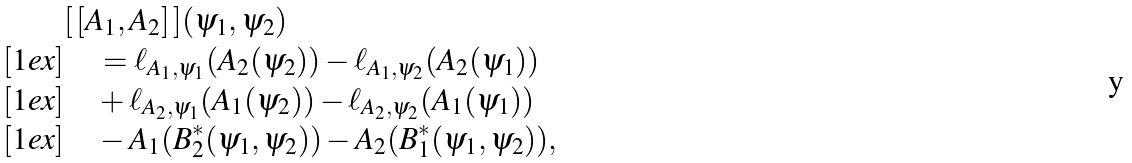Convert formula to latex. <formula><loc_0><loc_0><loc_500><loc_500>& [ \, [ A _ { 1 } , A _ { 2 } ] \, ] ( \psi _ { 1 } , \psi _ { 2 } ) \\ [ 1 e x ] & \quad = \ell _ { A _ { 1 } , \psi _ { 1 } } ( A _ { 2 } ( \psi _ { 2 } ) ) - \ell _ { A _ { 1 } , \psi _ { 2 } } ( A _ { 2 } ( \psi _ { 1 } ) ) \\ [ 1 e x ] & \quad + \ell _ { A _ { 2 } , \psi _ { 1 } } ( A _ { 1 } ( \psi _ { 2 } ) ) - \ell _ { A _ { 2 } , \psi _ { 2 } } ( A _ { 1 } ( \psi _ { 1 } ) ) \\ [ 1 e x ] & \quad - A _ { 1 } ( B _ { 2 } ^ { * } ( \psi _ { 1 } , \psi _ { 2 } ) ) - A _ { 2 } ( B _ { 1 } ^ { * } ( \psi _ { 1 } , \psi _ { 2 } ) ) ,</formula> 